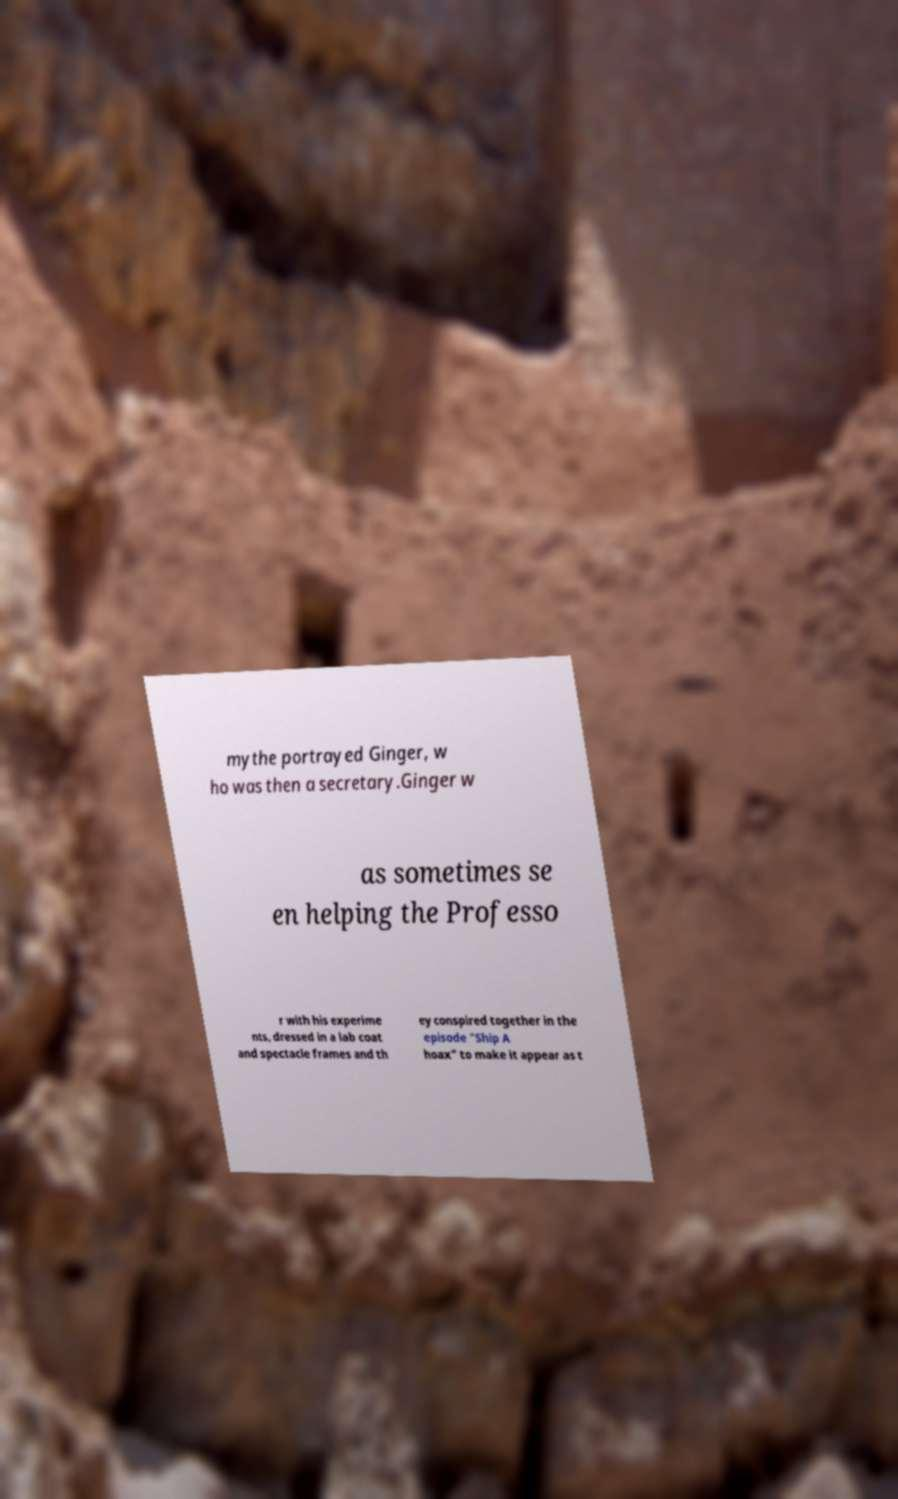For documentation purposes, I need the text within this image transcribed. Could you provide that? mythe portrayed Ginger, w ho was then a secretary.Ginger w as sometimes se en helping the Professo r with his experime nts, dressed in a lab coat and spectacle frames and th ey conspired together in the episode "Ship A hoax" to make it appear as t 